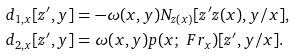<formula> <loc_0><loc_0><loc_500><loc_500>& d _ { 1 , x } [ z ^ { \prime } , y ] = - \omega ( x , y ) N _ { z ( x ) } [ z ^ { \prime } z ( x ) , y / x ] , \ \\ & d _ { 2 , x } [ z ^ { \prime } , y ] = \omega ( x , y ) p ( x ; \ F r _ { x } ) [ z ^ { \prime } , y / x ] .</formula> 